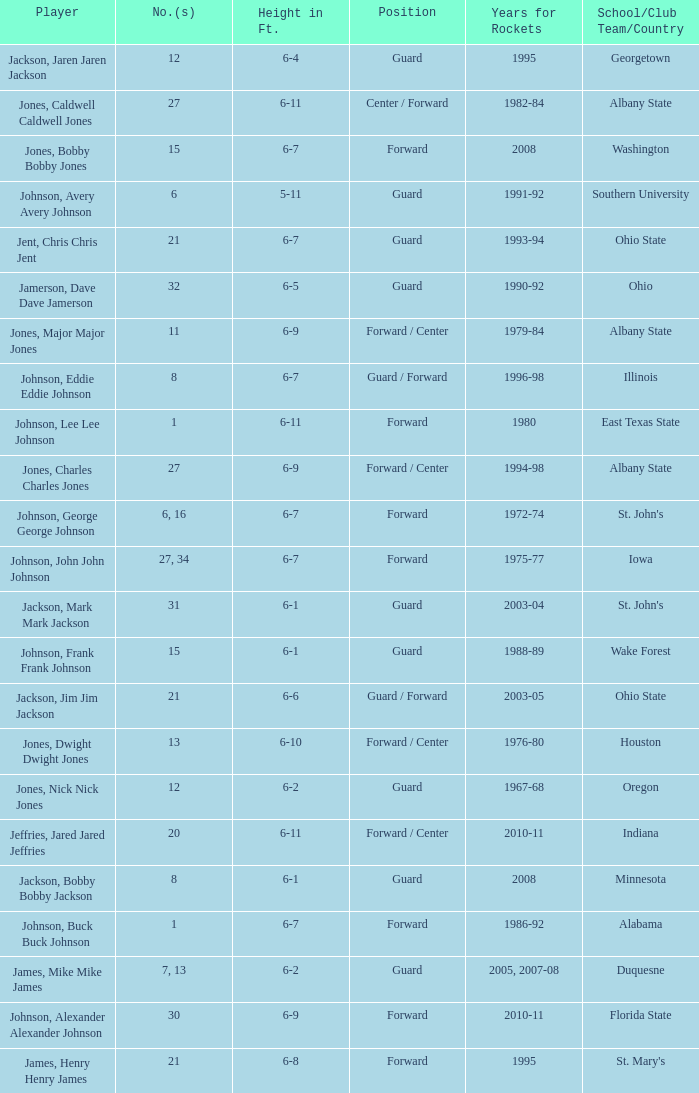How tall is the player jones, major major jones? 6-9. 